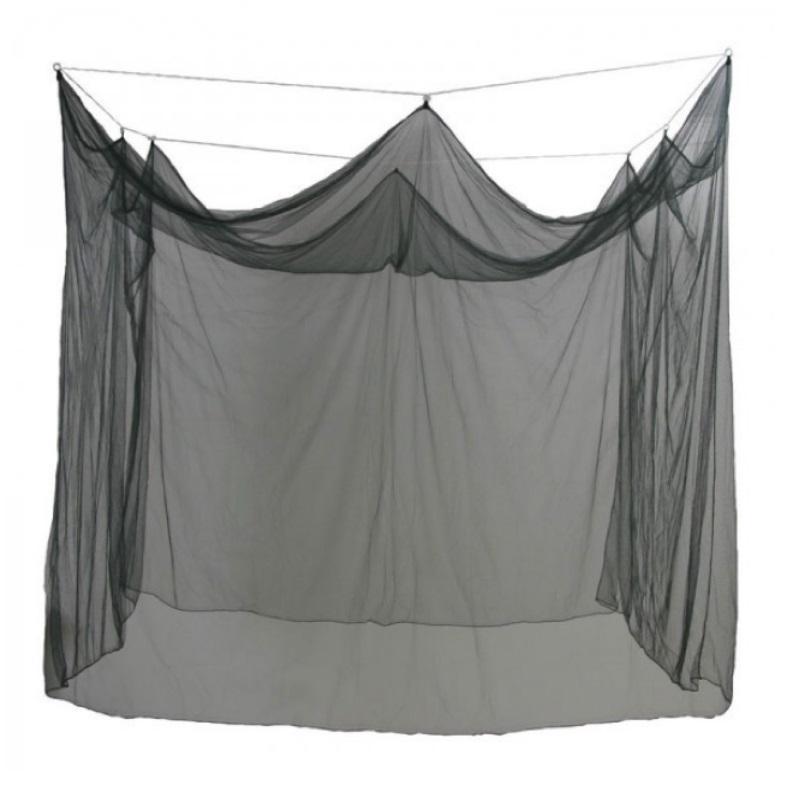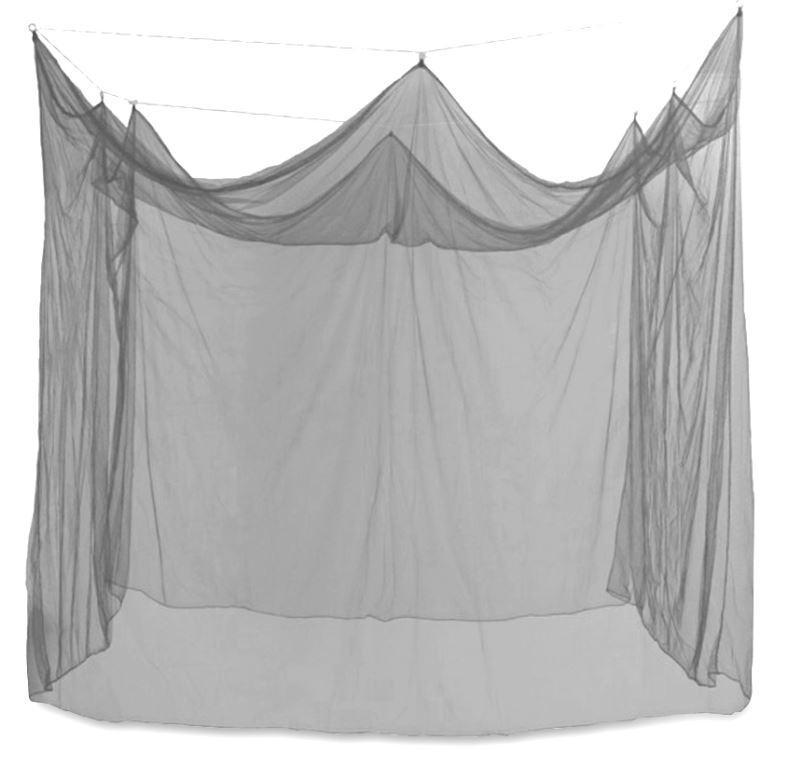The first image is the image on the left, the second image is the image on the right. Assess this claim about the two images: "There are two canopies with at least one mostly square one.". Correct or not? Answer yes or no. Yes. The first image is the image on the left, the second image is the image on the right. For the images shown, is this caption "The tents are both empty." true? Answer yes or no. Yes. 